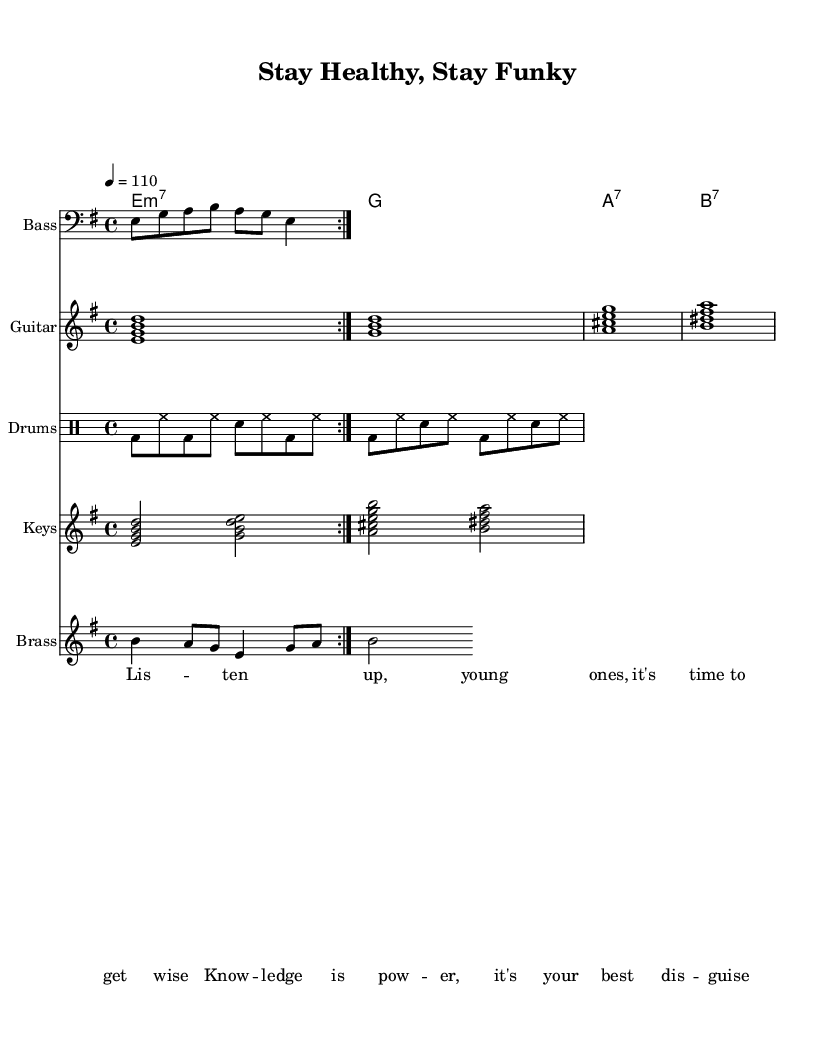What is the key signature of this music? The key signature is indicated by the presence of two sharps, which corresponds to the key of B minor or D major. However, since the piece starts with the chords E minor, the key signature aligns with the E minor scale.
Answer: E minor What is the time signature of this music? The time signature is shown at the beginning of the sheet music, which indicates that there are four beats in each measure, represented as 4/4.
Answer: 4/4 What is the tempo marking of the piece? The tempo is indicated by the notation that states "4 = 110," meaning there are 110 beats played per minute. This information is typically found at the beginning of the score.
Answer: 110 How many measures are in the bass riff? The bass riff consists of two repeated sections, indicating that there are 8 beats per section, which totals to 2 measures. Each repetition counts as one measure.
Answer: 2 measures What instrument plays the drum pattern? The drum pattern is notated in a separate staff labeled "Drums," which indicates that this staff is specifically for percussion instruments.
Answer: Drums What is the chord progression in the guitar part? By looking at the chordmode section, we see the specific chords listed, which sequence from E minor 7 to G, then to A7, and finally to B7. The structure reveals the progression directly.
Answer: E minor 7 to G to A7 to B7 What theme does the lyrical content in the music address? The lyrics suggest a focus on empowerment and knowledge, as evident in phrases like "knowledge is power," which reflects a socially conscious message targeted at young listeners.
Answer: Health education and youth empowerment 